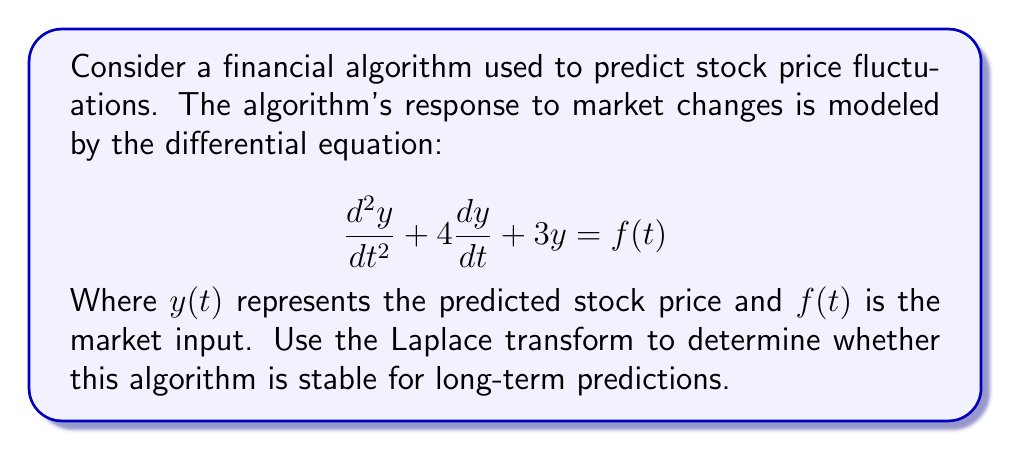What is the answer to this math problem? To analyze the stability of the algorithm using Laplace transforms, we follow these steps:

1) First, we take the Laplace transform of both sides of the equation. Let $Y(s)$ be the Laplace transform of $y(t)$ and $F(s)$ be the Laplace transform of $f(t)$. Assuming zero initial conditions:

   $$\mathcal{L}\{y''(t)\} + 4\mathcal{L}\{y'(t)\} + 3\mathcal{L}\{y(t)\} = \mathcal{L}\{f(t)\}$$

2) Using Laplace transform properties:

   $$s^2Y(s) + 4sY(s) + 3Y(s) = F(s)$$

3) Factoring out $Y(s)$:

   $$(s^2 + 4s + 3)Y(s) = F(s)$$

4) The transfer function $H(s)$ of the system is:

   $$H(s) = \frac{Y(s)}{F(s)} = \frac{1}{s^2 + 4s + 3}$$

5) To determine stability, we need to find the poles of $H(s)$. These are the roots of the characteristic equation:

   $$s^2 + 4s + 3 = 0$$

6) Using the quadratic formula:

   $$s = \frac{-4 \pm \sqrt{16 - 12}}{2} = \frac{-4 \pm 2}{2}$$

7) The poles are:

   $$s_1 = -3 \quad \text{and} \quad s_2 = -1$$

8) For a system to be stable, all poles must have negative real parts. In this case, both poles are real and negative.

Therefore, the algorithm is stable for long-term predictions. The negative real poles indicate that any transient responses will decay over time, leading to a stable prediction.
Answer: The algorithm is stable for long-term predictions. The poles of the transfer function are $s_1 = -3$ and $s_2 = -1$, which are both real and negative, indicating asymptotic stability. 